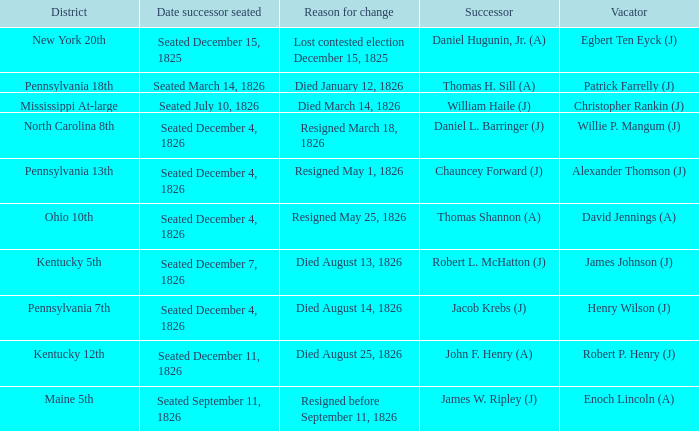Name the vacator for died august 13, 1826 James Johnson (J). 